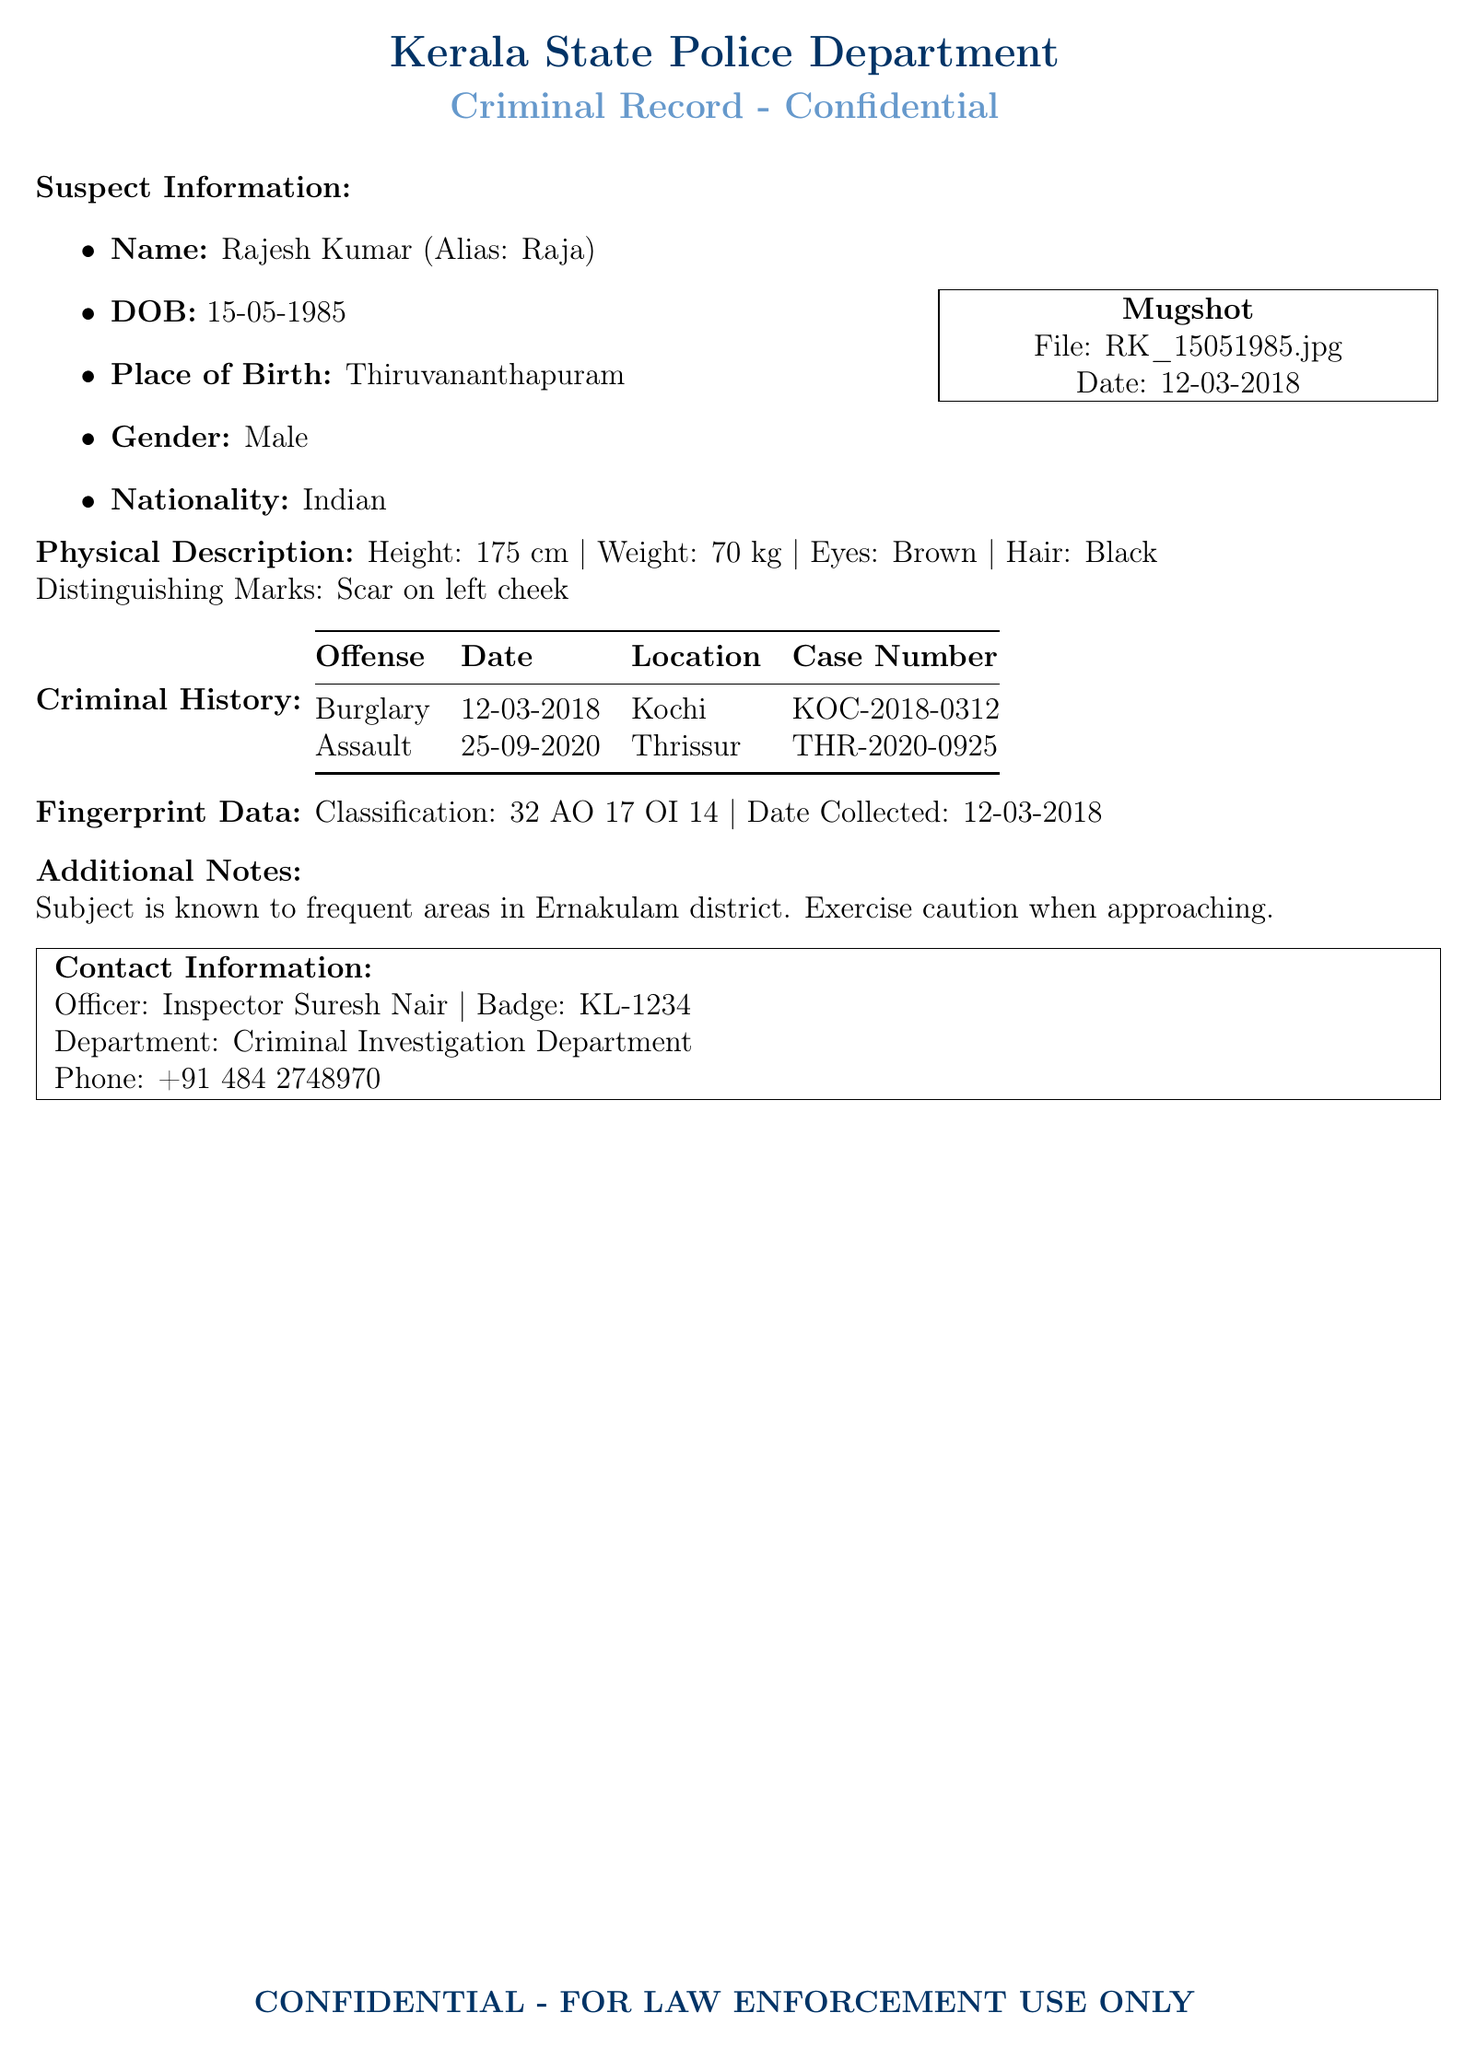What is the suspect's name? The suspect's name is listed in the document.
Answer: Rajesh Kumar What is the suspect's date of birth? The document provides the date of birth in the suspect information section.
Answer: 15-05-1985 What is the height of the suspect? The physical description section includes the suspect's height.
Answer: 175 cm What offense was committed on 12-03-2018? The criminal history section specifies the offense committed on that date.
Answer: Burglary What is the case number for the assault charge? The table lists the case number associated with the assault charge.
Answer: THR-2020-0925 How much does the suspect weigh? The suspect's weight is found in the physical description section.
Answer: 70 kg Where was the last recorded offense committed? The document mentions the location of the offense in the criminal history section.
Answer: Thrissur Who is the contact officer listed in the document? The last section of the document provides the name of the officer.
Answer: Inspector Suresh Nair What is the color of the suspect's hair? The physical description includes the hair color of the suspect.
Answer: Black 